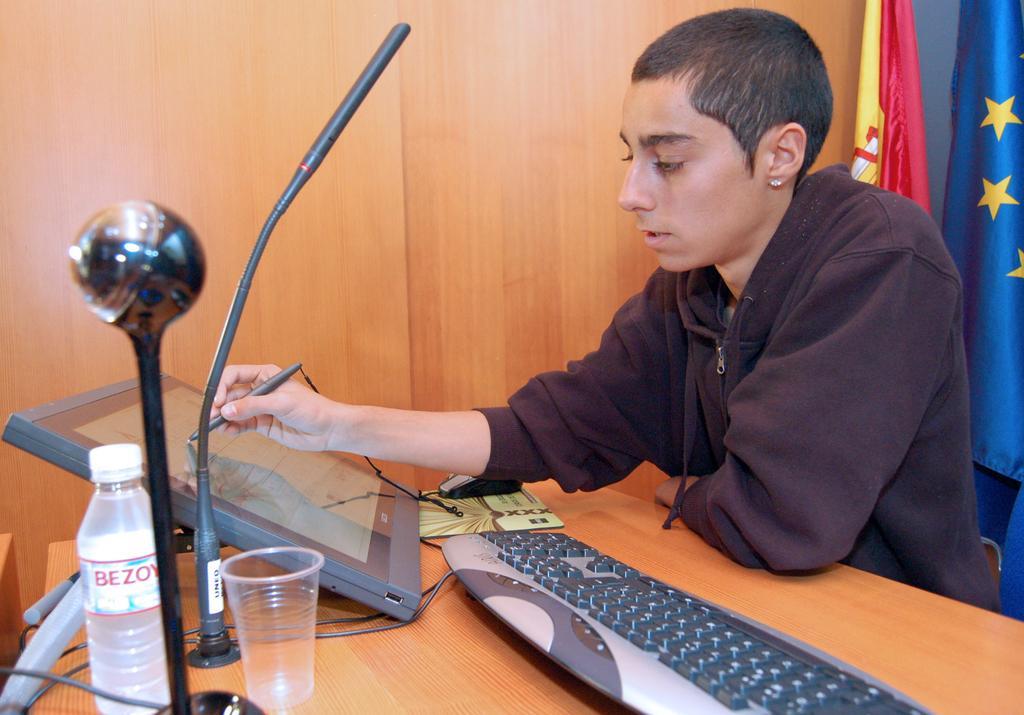How would you summarize this image in a sentence or two? This person sitting and holding pen. We can see screen,keyboard,mouse,book,glass,bottle,cable on the table. On the background we can see wooden wall,flags. 